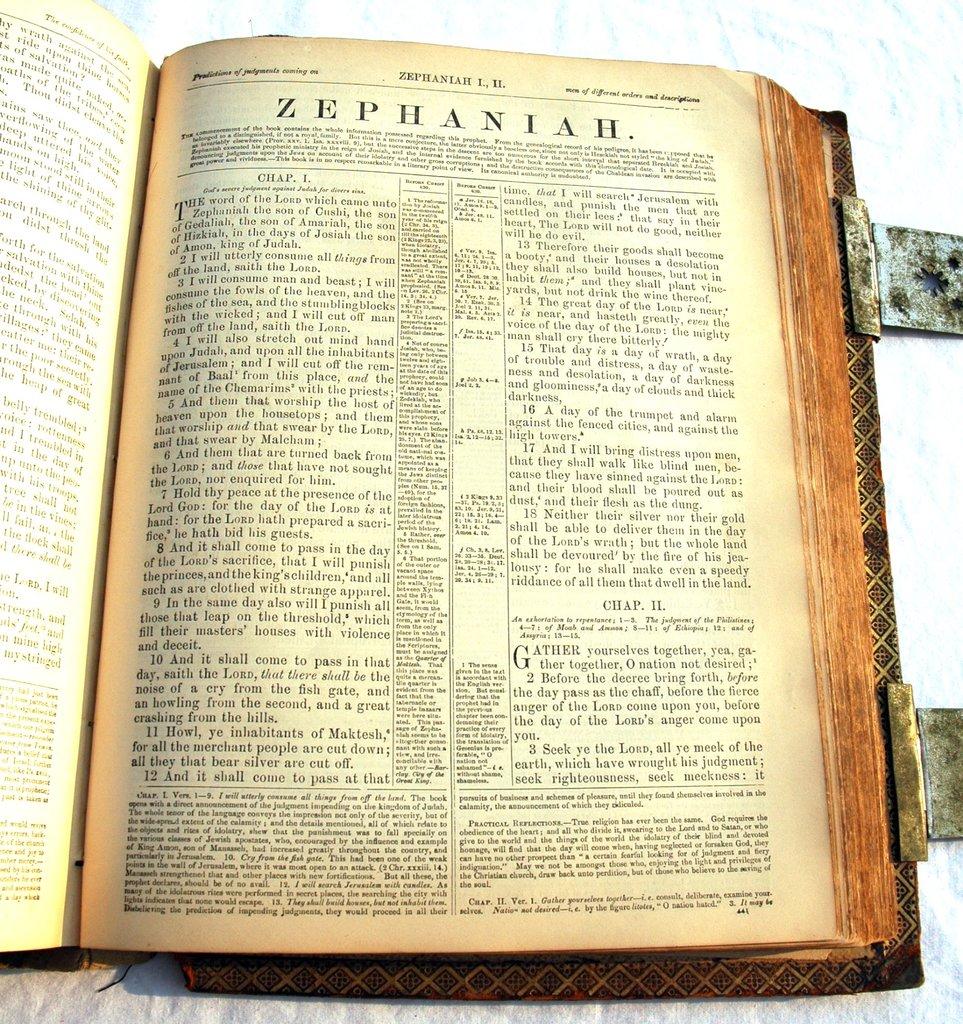What is the first word of chapter 2?
Your answer should be very brief. Gather. 